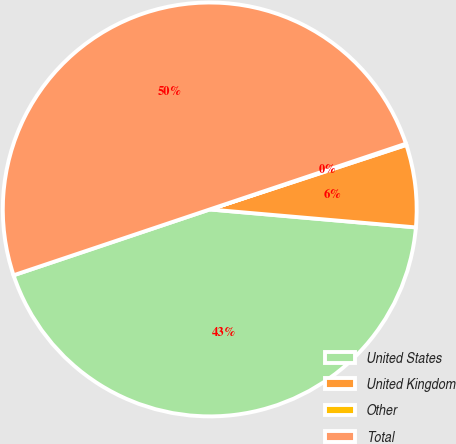Convert chart to OTSL. <chart><loc_0><loc_0><loc_500><loc_500><pie_chart><fcel>United States<fcel>United Kingdom<fcel>Other<fcel>Total<nl><fcel>43.46%<fcel>6.43%<fcel>0.1%<fcel>50.0%<nl></chart> 